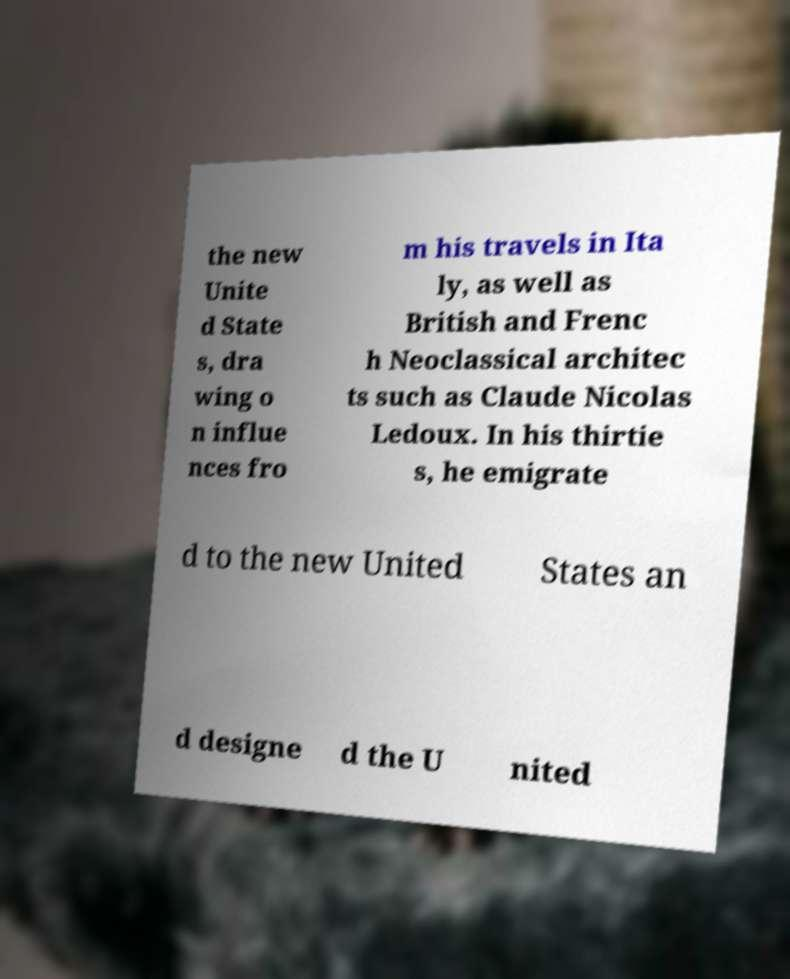There's text embedded in this image that I need extracted. Can you transcribe it verbatim? the new Unite d State s, dra wing o n influe nces fro m his travels in Ita ly, as well as British and Frenc h Neoclassical architec ts such as Claude Nicolas Ledoux. In his thirtie s, he emigrate d to the new United States an d designe d the U nited 